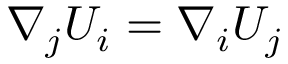<formula> <loc_0><loc_0><loc_500><loc_500>\nabla _ { j } U _ { i } = \nabla _ { i } U _ { j }</formula> 